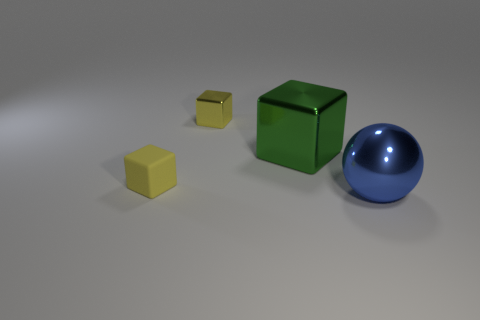Is the big thing that is behind the large metal ball made of the same material as the yellow block on the right side of the small matte object?
Provide a succinct answer. Yes. What material is the other block that is the same color as the matte block?
Your answer should be very brief. Metal. What number of small yellow matte things have the same shape as the big green metallic object?
Your answer should be very brief. 1. Is the number of metallic spheres that are on the left side of the blue object greater than the number of yellow metallic things?
Your answer should be very brief. No. There is a blue metallic thing in front of the large metallic thing to the left of the large metal object that is on the right side of the green cube; what is its shape?
Provide a short and direct response. Sphere. Does the large blue object in front of the small shiny object have the same shape as the yellow thing that is behind the small yellow rubber block?
Provide a short and direct response. No. Is there any other thing that is the same size as the rubber block?
Provide a short and direct response. Yes. What number of spheres are small red things or yellow objects?
Make the answer very short. 0. Does the large ball have the same material as the big green thing?
Your response must be concise. Yes. What number of other things are there of the same color as the matte cube?
Offer a terse response. 1. 